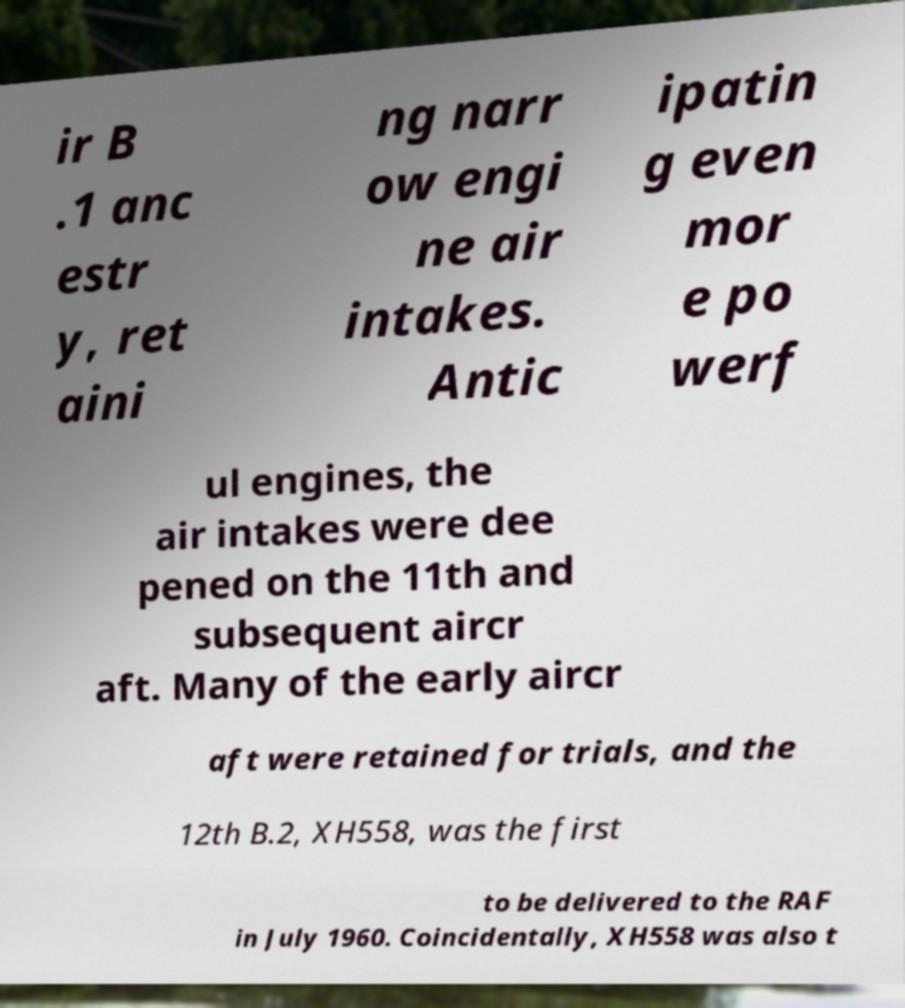Can you accurately transcribe the text from the provided image for me? ir B .1 anc estr y, ret aini ng narr ow engi ne air intakes. Antic ipatin g even mor e po werf ul engines, the air intakes were dee pened on the 11th and subsequent aircr aft. Many of the early aircr aft were retained for trials, and the 12th B.2, XH558, was the first to be delivered to the RAF in July 1960. Coincidentally, XH558 was also t 